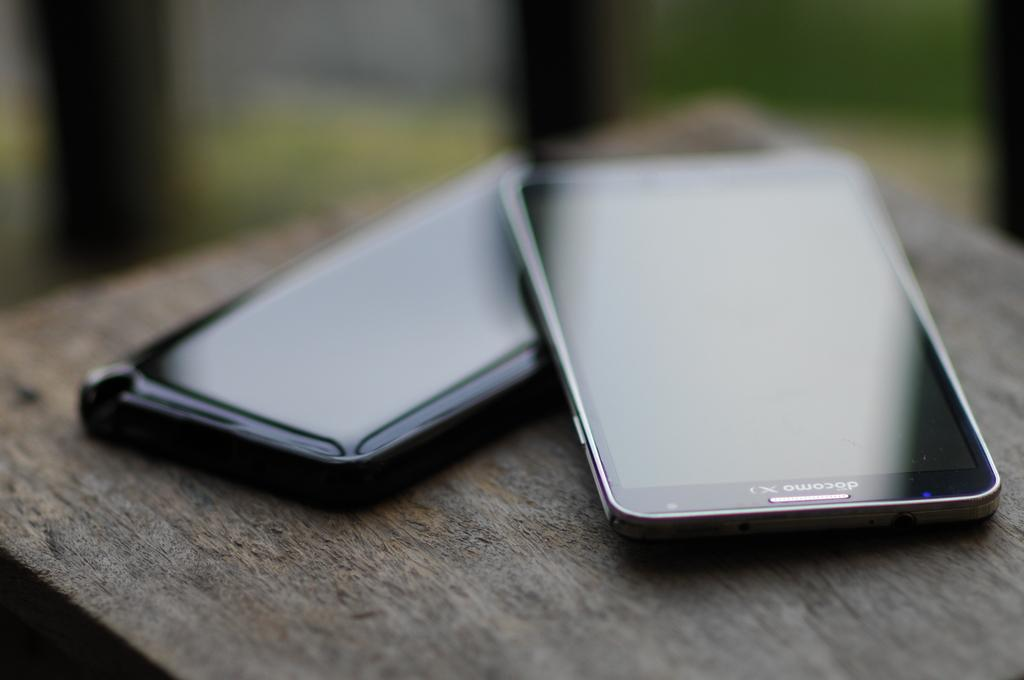<image>
Present a compact description of the photo's key features. Two smart phones, one of them a docomo. 